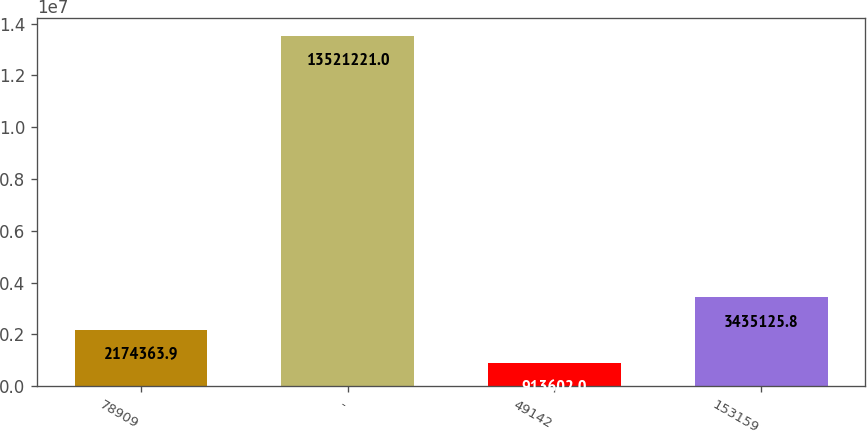<chart> <loc_0><loc_0><loc_500><loc_500><bar_chart><fcel>78909<fcel>-<fcel>49142<fcel>153159<nl><fcel>2.17436e+06<fcel>1.35212e+07<fcel>913602<fcel>3.43513e+06<nl></chart> 